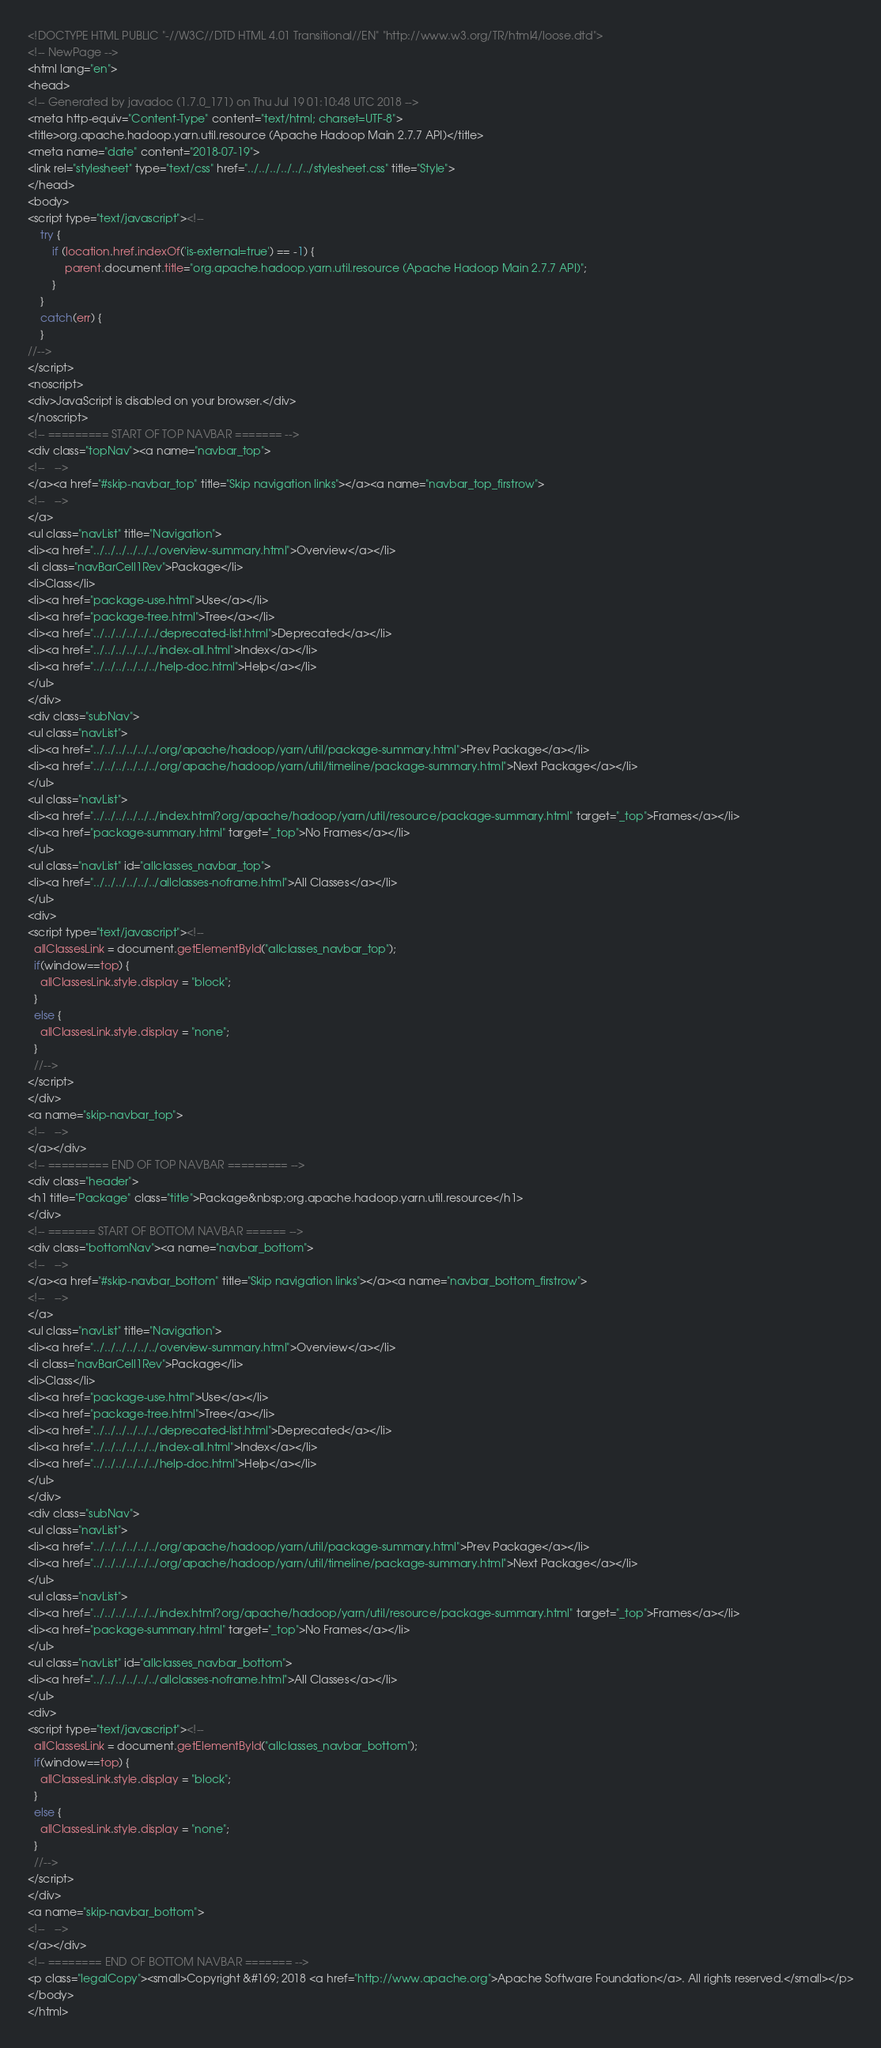<code> <loc_0><loc_0><loc_500><loc_500><_HTML_><!DOCTYPE HTML PUBLIC "-//W3C//DTD HTML 4.01 Transitional//EN" "http://www.w3.org/TR/html4/loose.dtd">
<!-- NewPage -->
<html lang="en">
<head>
<!-- Generated by javadoc (1.7.0_171) on Thu Jul 19 01:10:48 UTC 2018 -->
<meta http-equiv="Content-Type" content="text/html; charset=UTF-8">
<title>org.apache.hadoop.yarn.util.resource (Apache Hadoop Main 2.7.7 API)</title>
<meta name="date" content="2018-07-19">
<link rel="stylesheet" type="text/css" href="../../../../../../stylesheet.css" title="Style">
</head>
<body>
<script type="text/javascript"><!--
    try {
        if (location.href.indexOf('is-external=true') == -1) {
            parent.document.title="org.apache.hadoop.yarn.util.resource (Apache Hadoop Main 2.7.7 API)";
        }
    }
    catch(err) {
    }
//-->
</script>
<noscript>
<div>JavaScript is disabled on your browser.</div>
</noscript>
<!-- ========= START OF TOP NAVBAR ======= -->
<div class="topNav"><a name="navbar_top">
<!--   -->
</a><a href="#skip-navbar_top" title="Skip navigation links"></a><a name="navbar_top_firstrow">
<!--   -->
</a>
<ul class="navList" title="Navigation">
<li><a href="../../../../../../overview-summary.html">Overview</a></li>
<li class="navBarCell1Rev">Package</li>
<li>Class</li>
<li><a href="package-use.html">Use</a></li>
<li><a href="package-tree.html">Tree</a></li>
<li><a href="../../../../../../deprecated-list.html">Deprecated</a></li>
<li><a href="../../../../../../index-all.html">Index</a></li>
<li><a href="../../../../../../help-doc.html">Help</a></li>
</ul>
</div>
<div class="subNav">
<ul class="navList">
<li><a href="../../../../../../org/apache/hadoop/yarn/util/package-summary.html">Prev Package</a></li>
<li><a href="../../../../../../org/apache/hadoop/yarn/util/timeline/package-summary.html">Next Package</a></li>
</ul>
<ul class="navList">
<li><a href="../../../../../../index.html?org/apache/hadoop/yarn/util/resource/package-summary.html" target="_top">Frames</a></li>
<li><a href="package-summary.html" target="_top">No Frames</a></li>
</ul>
<ul class="navList" id="allclasses_navbar_top">
<li><a href="../../../../../../allclasses-noframe.html">All Classes</a></li>
</ul>
<div>
<script type="text/javascript"><!--
  allClassesLink = document.getElementById("allclasses_navbar_top");
  if(window==top) {
    allClassesLink.style.display = "block";
  }
  else {
    allClassesLink.style.display = "none";
  }
  //-->
</script>
</div>
<a name="skip-navbar_top">
<!--   -->
</a></div>
<!-- ========= END OF TOP NAVBAR ========= -->
<div class="header">
<h1 title="Package" class="title">Package&nbsp;org.apache.hadoop.yarn.util.resource</h1>
</div>
<!-- ======= START OF BOTTOM NAVBAR ====== -->
<div class="bottomNav"><a name="navbar_bottom">
<!--   -->
</a><a href="#skip-navbar_bottom" title="Skip navigation links"></a><a name="navbar_bottom_firstrow">
<!--   -->
</a>
<ul class="navList" title="Navigation">
<li><a href="../../../../../../overview-summary.html">Overview</a></li>
<li class="navBarCell1Rev">Package</li>
<li>Class</li>
<li><a href="package-use.html">Use</a></li>
<li><a href="package-tree.html">Tree</a></li>
<li><a href="../../../../../../deprecated-list.html">Deprecated</a></li>
<li><a href="../../../../../../index-all.html">Index</a></li>
<li><a href="../../../../../../help-doc.html">Help</a></li>
</ul>
</div>
<div class="subNav">
<ul class="navList">
<li><a href="../../../../../../org/apache/hadoop/yarn/util/package-summary.html">Prev Package</a></li>
<li><a href="../../../../../../org/apache/hadoop/yarn/util/timeline/package-summary.html">Next Package</a></li>
</ul>
<ul class="navList">
<li><a href="../../../../../../index.html?org/apache/hadoop/yarn/util/resource/package-summary.html" target="_top">Frames</a></li>
<li><a href="package-summary.html" target="_top">No Frames</a></li>
</ul>
<ul class="navList" id="allclasses_navbar_bottom">
<li><a href="../../../../../../allclasses-noframe.html">All Classes</a></li>
</ul>
<div>
<script type="text/javascript"><!--
  allClassesLink = document.getElementById("allclasses_navbar_bottom");
  if(window==top) {
    allClassesLink.style.display = "block";
  }
  else {
    allClassesLink.style.display = "none";
  }
  //-->
</script>
</div>
<a name="skip-navbar_bottom">
<!--   -->
</a></div>
<!-- ======== END OF BOTTOM NAVBAR ======= -->
<p class="legalCopy"><small>Copyright &#169; 2018 <a href="http://www.apache.org">Apache Software Foundation</a>. All rights reserved.</small></p>
</body>
</html>
</code> 